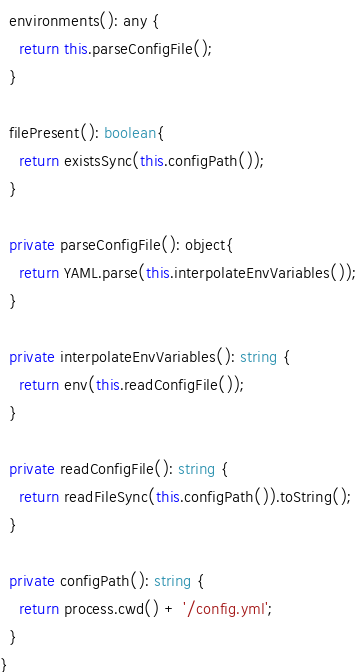Convert code to text. <code><loc_0><loc_0><loc_500><loc_500><_TypeScript_>  environments(): any {
    return this.parseConfigFile();
  }

  filePresent(): boolean{
    return existsSync(this.configPath());
  }

  private parseConfigFile(): object{
    return YAML.parse(this.interpolateEnvVariables());
  }

  private interpolateEnvVariables(): string {
    return env(this.readConfigFile());
  }

  private readConfigFile(): string {
    return readFileSync(this.configPath()).toString();
  }

  private configPath(): string {
    return process.cwd() + '/config.yml';
  }
}
</code> 